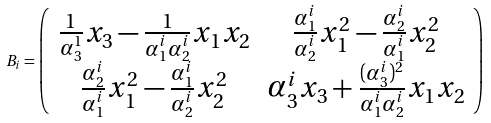Convert formula to latex. <formula><loc_0><loc_0><loc_500><loc_500>B _ { i } = \left ( \begin{array} { c c } \frac { 1 } { \alpha _ { 3 } ^ { 1 } } x _ { 3 } - \frac { 1 } { \alpha _ { 1 } ^ { i } \alpha _ { 2 } ^ { i } } x _ { 1 } x _ { 2 } & \frac { \alpha _ { 1 } ^ { i } } { \alpha _ { 2 } ^ { i } } x _ { 1 } ^ { 2 } - \frac { \alpha _ { 2 } ^ { i } } { \alpha _ { 1 } ^ { i } } x _ { 2 } ^ { 2 } \\ \frac { \alpha _ { 2 } ^ { i } } { \alpha _ { 1 } ^ { i } } x _ { 1 } ^ { 2 } - \frac { \alpha _ { 1 } ^ { i } } { \alpha _ { 2 } ^ { i } } x _ { 2 } ^ { 2 } & \alpha _ { 3 } ^ { i } x _ { 3 } + \frac { ( \alpha _ { 3 } ^ { i } ) ^ { 2 } } { \alpha _ { 1 } ^ { i } \alpha _ { 2 } ^ { i } } x _ { 1 } x _ { 2 } \end{array} \right )</formula> 